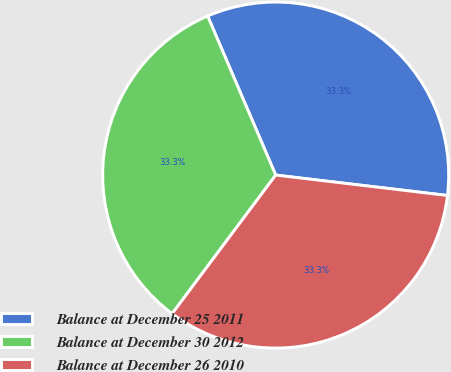<chart> <loc_0><loc_0><loc_500><loc_500><pie_chart><fcel>Balance at December 25 2011<fcel>Balance at December 30 2012<fcel>Balance at December 26 2010<nl><fcel>33.32%<fcel>33.35%<fcel>33.33%<nl></chart> 